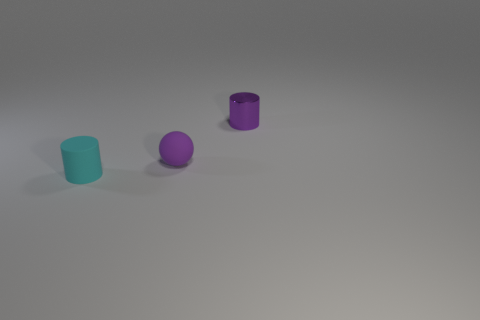Add 3 tiny matte objects. How many objects exist? 6 Subtract all cylinders. How many objects are left? 1 Subtract all large green rubber balls. Subtract all tiny cylinders. How many objects are left? 1 Add 1 tiny purple spheres. How many tiny purple spheres are left? 2 Add 1 small green metal spheres. How many small green metal spheres exist? 1 Subtract 0 gray blocks. How many objects are left? 3 